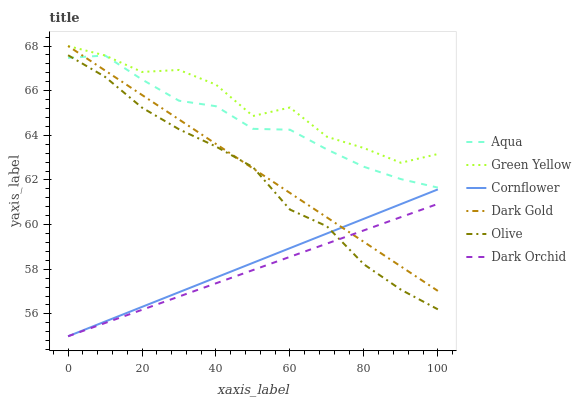Does Dark Orchid have the minimum area under the curve?
Answer yes or no. Yes. Does Green Yellow have the maximum area under the curve?
Answer yes or no. Yes. Does Dark Gold have the minimum area under the curve?
Answer yes or no. No. Does Dark Gold have the maximum area under the curve?
Answer yes or no. No. Is Dark Orchid the smoothest?
Answer yes or no. Yes. Is Green Yellow the roughest?
Answer yes or no. Yes. Is Dark Gold the smoothest?
Answer yes or no. No. Is Dark Gold the roughest?
Answer yes or no. No. Does Cornflower have the lowest value?
Answer yes or no. Yes. Does Dark Gold have the lowest value?
Answer yes or no. No. Does Green Yellow have the highest value?
Answer yes or no. Yes. Does Aqua have the highest value?
Answer yes or no. No. Is Dark Orchid less than Green Yellow?
Answer yes or no. Yes. Is Aqua greater than Dark Orchid?
Answer yes or no. Yes. Does Dark Gold intersect Aqua?
Answer yes or no. Yes. Is Dark Gold less than Aqua?
Answer yes or no. No. Is Dark Gold greater than Aqua?
Answer yes or no. No. Does Dark Orchid intersect Green Yellow?
Answer yes or no. No. 